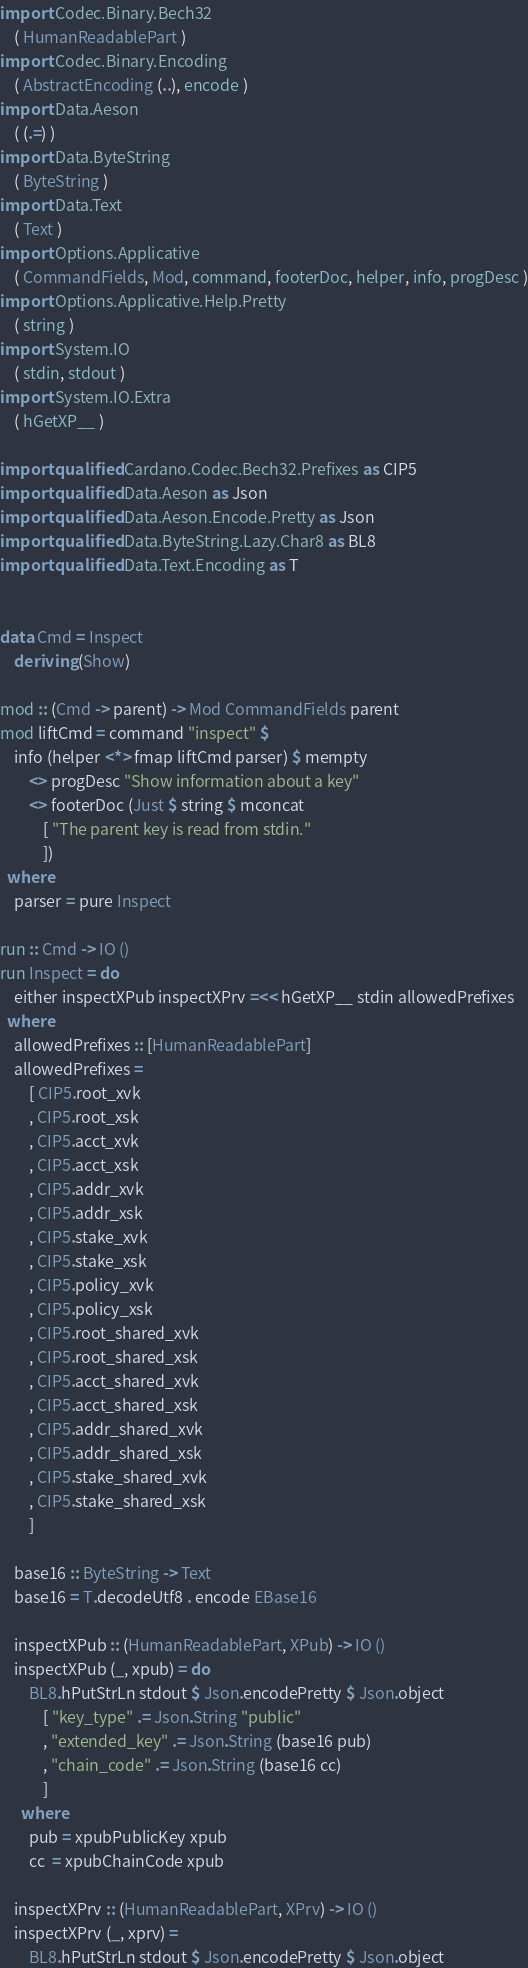Convert code to text. <code><loc_0><loc_0><loc_500><loc_500><_Haskell_>import Codec.Binary.Bech32
    ( HumanReadablePart )
import Codec.Binary.Encoding
    ( AbstractEncoding (..), encode )
import Data.Aeson
    ( (.=) )
import Data.ByteString
    ( ByteString )
import Data.Text
    ( Text )
import Options.Applicative
    ( CommandFields, Mod, command, footerDoc, helper, info, progDesc )
import Options.Applicative.Help.Pretty
    ( string )
import System.IO
    ( stdin, stdout )
import System.IO.Extra
    ( hGetXP__ )

import qualified Cardano.Codec.Bech32.Prefixes as CIP5
import qualified Data.Aeson as Json
import qualified Data.Aeson.Encode.Pretty as Json
import qualified Data.ByteString.Lazy.Char8 as BL8
import qualified Data.Text.Encoding as T


data Cmd = Inspect
    deriving (Show)

mod :: (Cmd -> parent) -> Mod CommandFields parent
mod liftCmd = command "inspect" $
    info (helper <*> fmap liftCmd parser) $ mempty
        <> progDesc "Show information about a key"
        <> footerDoc (Just $ string $ mconcat
            [ "The parent key is read from stdin."
            ])
  where
    parser = pure Inspect

run :: Cmd -> IO ()
run Inspect = do
    either inspectXPub inspectXPrv =<< hGetXP__ stdin allowedPrefixes
  where
    allowedPrefixes :: [HumanReadablePart]
    allowedPrefixes =
        [ CIP5.root_xvk
        , CIP5.root_xsk
        , CIP5.acct_xvk
        , CIP5.acct_xsk
        , CIP5.addr_xvk
        , CIP5.addr_xsk
        , CIP5.stake_xvk
        , CIP5.stake_xsk
        , CIP5.policy_xvk
        , CIP5.policy_xsk
        , CIP5.root_shared_xvk
        , CIP5.root_shared_xsk
        , CIP5.acct_shared_xvk
        , CIP5.acct_shared_xsk
        , CIP5.addr_shared_xvk
        , CIP5.addr_shared_xsk
        , CIP5.stake_shared_xvk
        , CIP5.stake_shared_xsk
        ]

    base16 :: ByteString -> Text
    base16 = T.decodeUtf8 . encode EBase16

    inspectXPub :: (HumanReadablePart, XPub) -> IO ()
    inspectXPub (_, xpub) = do
        BL8.hPutStrLn stdout $ Json.encodePretty $ Json.object
            [ "key_type" .= Json.String "public"
            , "extended_key" .= Json.String (base16 pub)
            , "chain_code" .= Json.String (base16 cc)
            ]
      where
        pub = xpubPublicKey xpub
        cc  = xpubChainCode xpub

    inspectXPrv :: (HumanReadablePart, XPrv) -> IO ()
    inspectXPrv (_, xprv) =
        BL8.hPutStrLn stdout $ Json.encodePretty $ Json.object</code> 